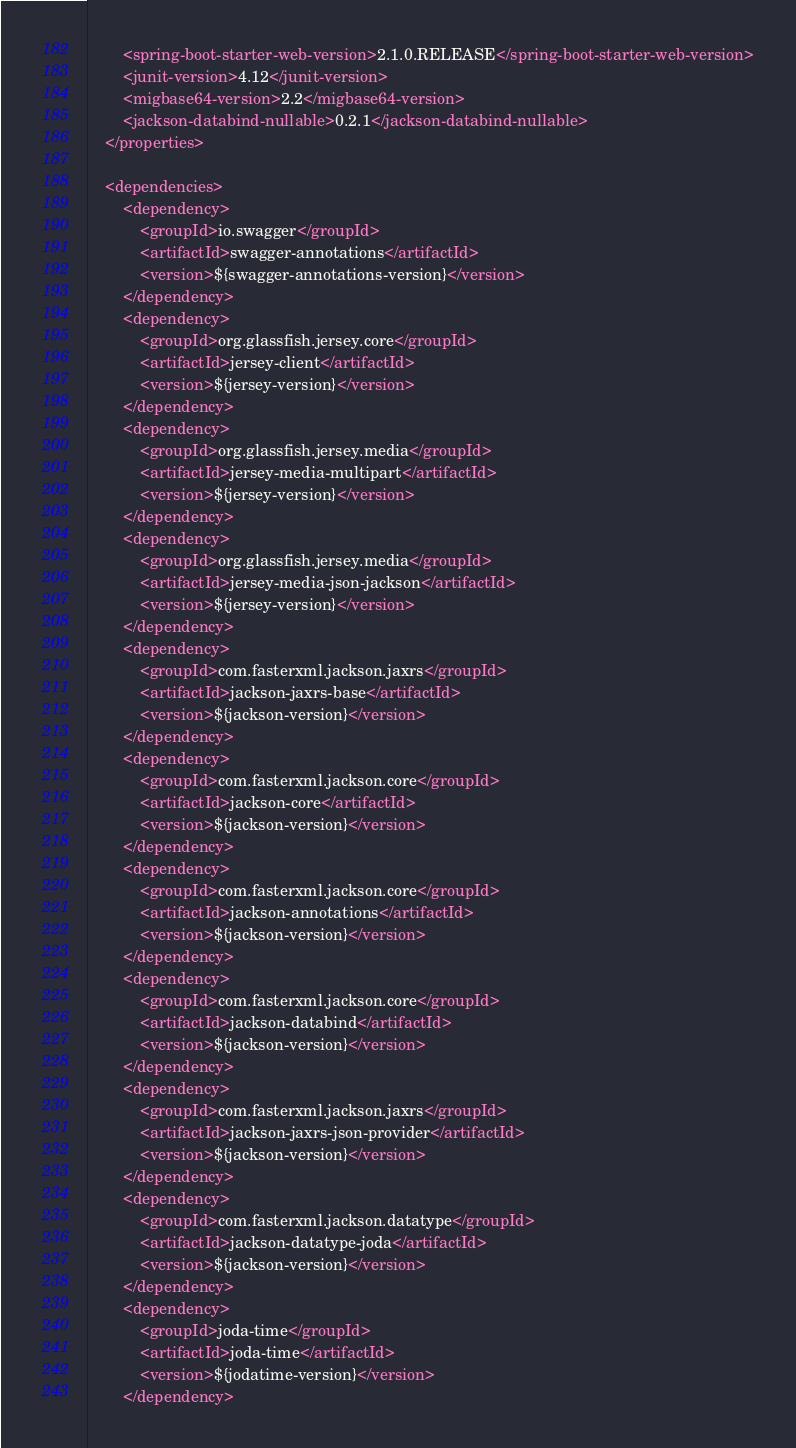<code> <loc_0><loc_0><loc_500><loc_500><_XML_>        <spring-boot-starter-web-version>2.1.0.RELEASE</spring-boot-starter-web-version>
        <junit-version>4.12</junit-version>
        <migbase64-version>2.2</migbase64-version>
        <jackson-databind-nullable>0.2.1</jackson-databind-nullable>
    </properties>

    <dependencies>
        <dependency>
            <groupId>io.swagger</groupId>
            <artifactId>swagger-annotations</artifactId>
            <version>${swagger-annotations-version}</version>
        </dependency>
        <dependency>
            <groupId>org.glassfish.jersey.core</groupId>
            <artifactId>jersey-client</artifactId>
            <version>${jersey-version}</version>
        </dependency>
        <dependency>
            <groupId>org.glassfish.jersey.media</groupId>
            <artifactId>jersey-media-multipart</artifactId>
            <version>${jersey-version}</version>
        </dependency>
        <dependency>
            <groupId>org.glassfish.jersey.media</groupId>
            <artifactId>jersey-media-json-jackson</artifactId>
            <version>${jersey-version}</version>
        </dependency>
        <dependency>
            <groupId>com.fasterxml.jackson.jaxrs</groupId>
            <artifactId>jackson-jaxrs-base</artifactId>
            <version>${jackson-version}</version>
        </dependency>
        <dependency>
            <groupId>com.fasterxml.jackson.core</groupId>
            <artifactId>jackson-core</artifactId>
            <version>${jackson-version}</version>
        </dependency>
        <dependency>
            <groupId>com.fasterxml.jackson.core</groupId>
            <artifactId>jackson-annotations</artifactId>
            <version>${jackson-version}</version>
        </dependency>
        <dependency>
            <groupId>com.fasterxml.jackson.core</groupId>
            <artifactId>jackson-databind</artifactId>
            <version>${jackson-version}</version>
        </dependency>
        <dependency>
            <groupId>com.fasterxml.jackson.jaxrs</groupId>
            <artifactId>jackson-jaxrs-json-provider</artifactId>
            <version>${jackson-version}</version>
        </dependency>
        <dependency>
            <groupId>com.fasterxml.jackson.datatype</groupId>
            <artifactId>jackson-datatype-joda</artifactId>
            <version>${jackson-version}</version>
        </dependency>
        <dependency>
            <groupId>joda-time</groupId>
            <artifactId>joda-time</artifactId>
            <version>${jodatime-version}</version>
        </dependency></code> 